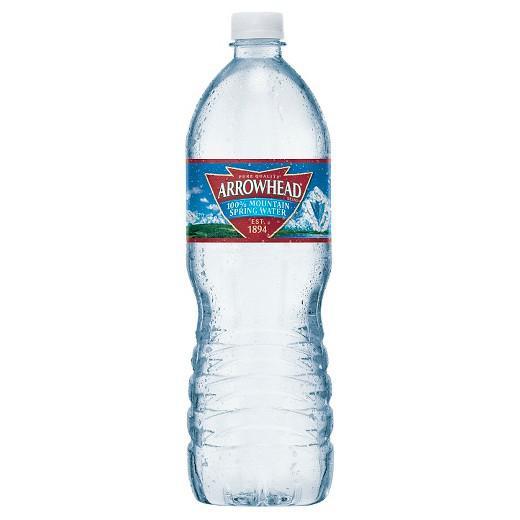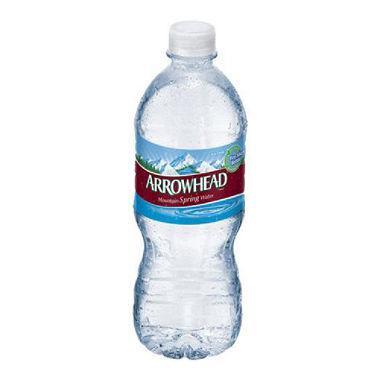The first image is the image on the left, the second image is the image on the right. Analyze the images presented: Is the assertion "Right and left images show a similarly shaped and sized non-stout bottle with a label and a white cap." valid? Answer yes or no. Yes. The first image is the image on the left, the second image is the image on the right. Given the left and right images, does the statement "There are two nearly identical bottles of water." hold true? Answer yes or no. Yes. 